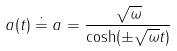<formula> <loc_0><loc_0><loc_500><loc_500>a ( t ) \doteq a = \frac { \sqrt { \omega } } { \cosh ( \pm \sqrt { \omega } t ) }</formula> 